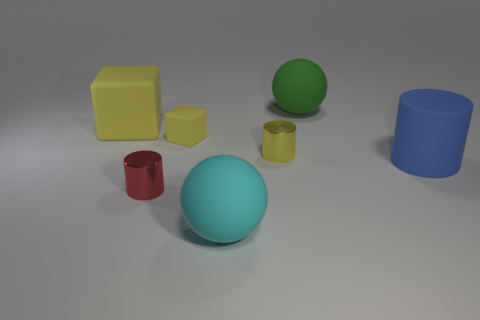Add 3 red shiny cylinders. How many objects exist? 10 Subtract all blocks. How many objects are left? 5 Add 3 big brown shiny cylinders. How many big brown shiny cylinders exist? 3 Subtract 0 red cubes. How many objects are left? 7 Subtract all large cyan metallic cylinders. Subtract all yellow metal cylinders. How many objects are left? 6 Add 4 small red metallic cylinders. How many small red metallic cylinders are left? 5 